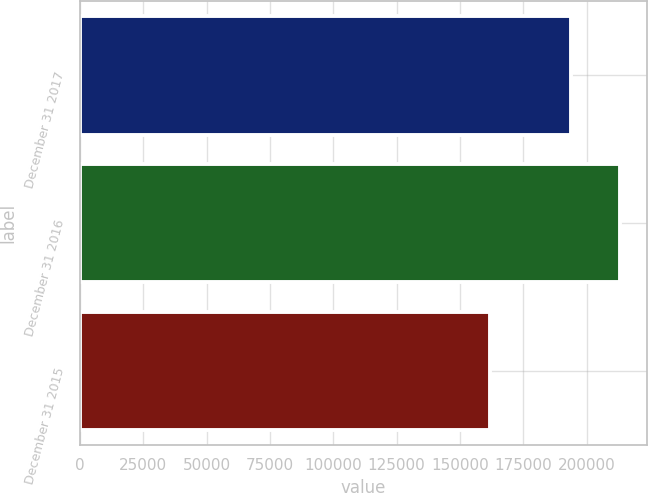<chart> <loc_0><loc_0><loc_500><loc_500><bar_chart><fcel>December 31 2017<fcel>December 31 2016<fcel>December 31 2015<nl><fcel>193871<fcel>213008<fcel>161923<nl></chart> 